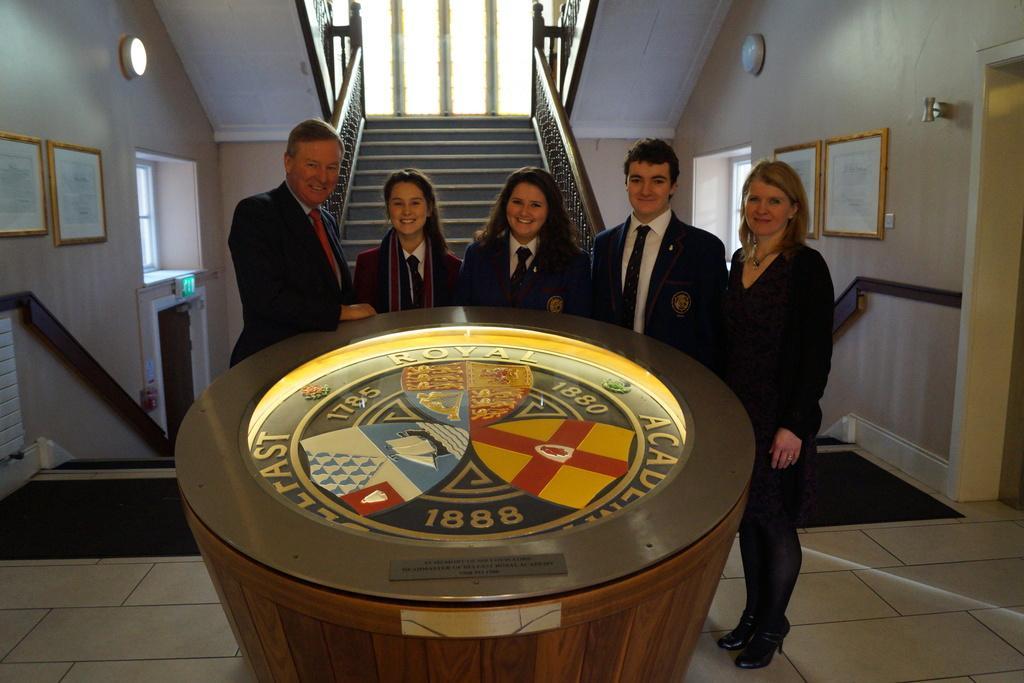How would you summarize this image in a sentence or two? This picture is clicked inside the hall. In the foreground we can see a wooden object seems to be the table containing the text, numbers and some logos. In the center we can see the group of people wearing suits, smiling and standing on the floor. On the right there is a woman wearing black color shrug, smiling and standing on the floor. In the background we can see the wall, wall mounted lamps, frames hanging on the wall and we can see the windows, door, staircase, railings and some other items. 